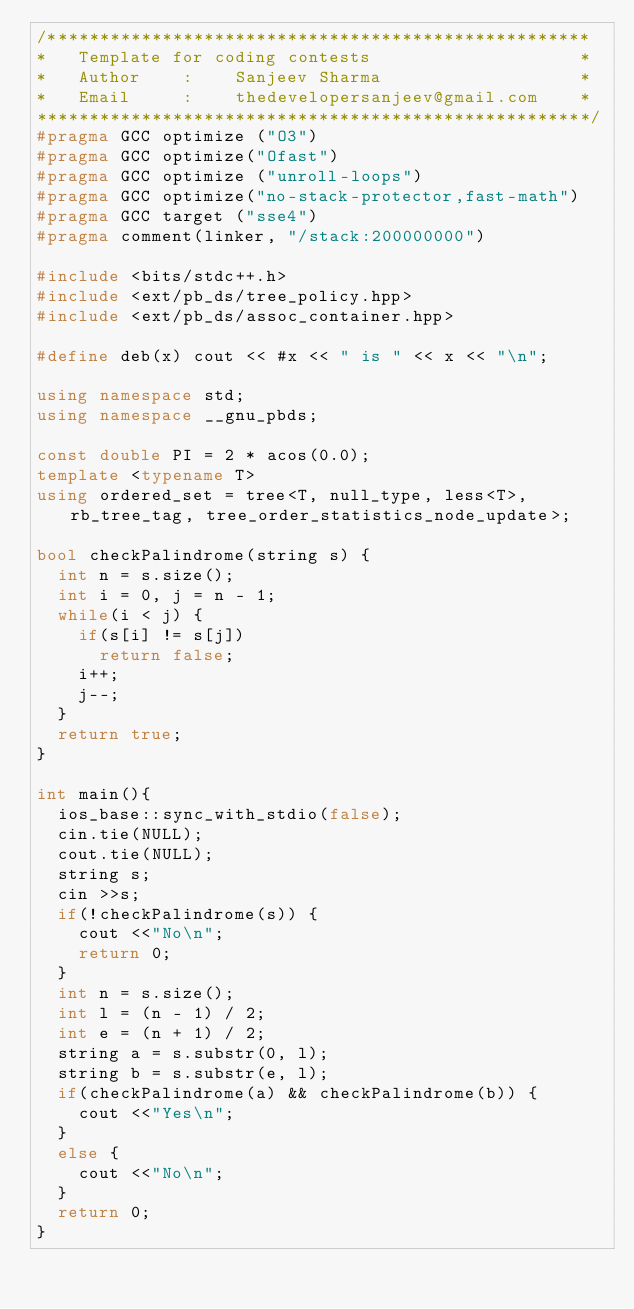Convert code to text. <code><loc_0><loc_0><loc_500><loc_500><_C++_>/****************************************************
*   Template for coding contests                    *
*   Author    :    Sanjeev Sharma                   *
*   Email     :    thedevelopersanjeev@gmail.com    *
*****************************************************/
#pragma GCC optimize ("O3")
#pragma GCC optimize("Ofast")
#pragma GCC optimize ("unroll-loops")
#pragma GCC optimize("no-stack-protector,fast-math")
#pragma GCC target ("sse4")
#pragma comment(linker, "/stack:200000000")

#include <bits/stdc++.h>
#include <ext/pb_ds/tree_policy.hpp>
#include <ext/pb_ds/assoc_container.hpp>

#define deb(x) cout << #x << " is " << x << "\n";

using namespace std;
using namespace __gnu_pbds;

const double PI = 2 * acos(0.0);
template <typename T>
using ordered_set = tree<T, null_type, less<T>, rb_tree_tag, tree_order_statistics_node_update>;

bool checkPalindrome(string s) {
	int n = s.size();
	int i = 0, j = n - 1;
	while(i < j) {
		if(s[i] != s[j])
			return false;
		i++;
		j--;
	}
	return true;
}

int main(){
	ios_base::sync_with_stdio(false);
	cin.tie(NULL);
	cout.tie(NULL);
	string s;
	cin >>s;
	if(!checkPalindrome(s)) {
		cout <<"No\n";
		return 0;
	}
	int n = s.size();
	int l = (n - 1) / 2;
	int e = (n + 1) / 2;
	string a = s.substr(0, l);
	string b = s.substr(e, l);
	if(checkPalindrome(a) && checkPalindrome(b)) {
		cout <<"Yes\n";
	}
	else {
		cout <<"No\n";
	}
	return 0;
}
</code> 